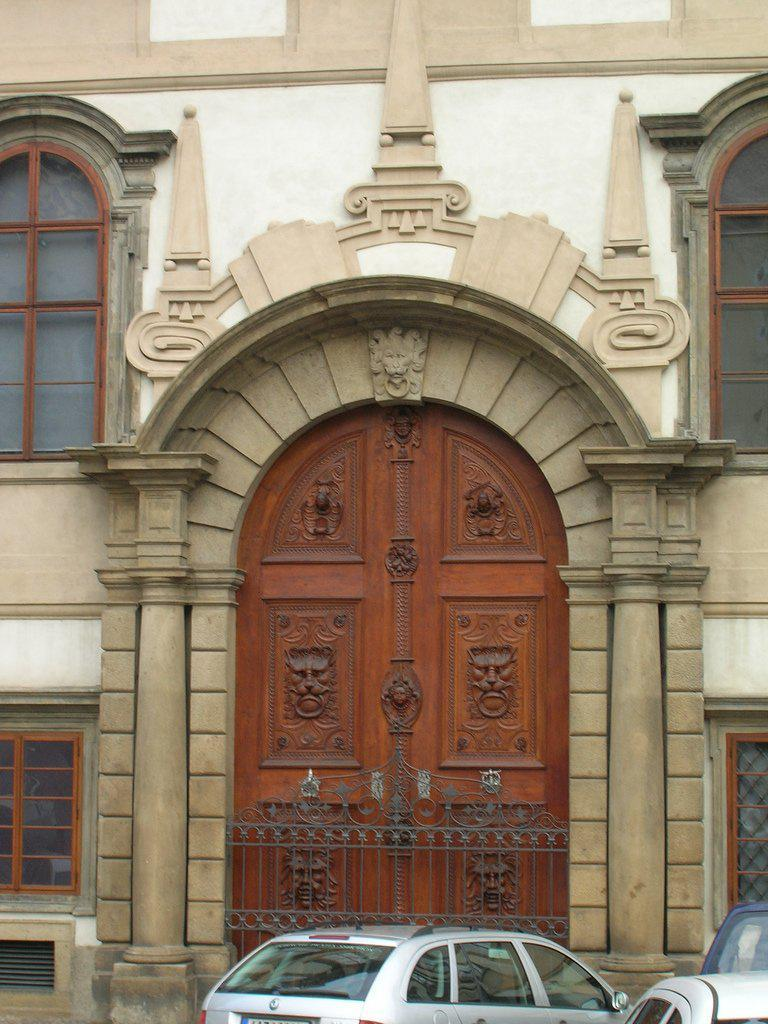What is the main structure visible in the image? There is a building in the image. What can be seen near the building? Cars are parked in front of the building. How many plants are growing on the leg of the person in the image? There is no person or leg visible in the image; it only features a building and parked cars. 